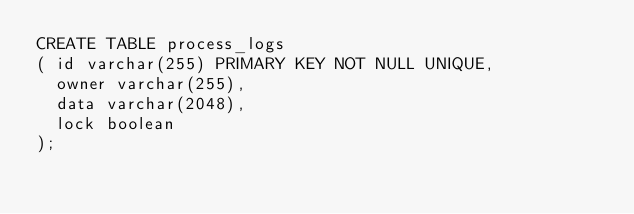Convert code to text. <code><loc_0><loc_0><loc_500><loc_500><_SQL_>CREATE TABLE process_logs
( id varchar(255) PRIMARY KEY NOT NULL UNIQUE,
  owner varchar(255),
  data varchar(2048),
  lock boolean
);
</code> 